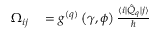<formula> <loc_0><loc_0><loc_500><loc_500>\begin{array} { r l } { \Omega _ { i j } } & = g ^ { ( q ) } \left ( \gamma , \phi \right ) \frac { \langle i | \hat { Q } _ { q } | j \rangle } { } } \end{array}</formula> 